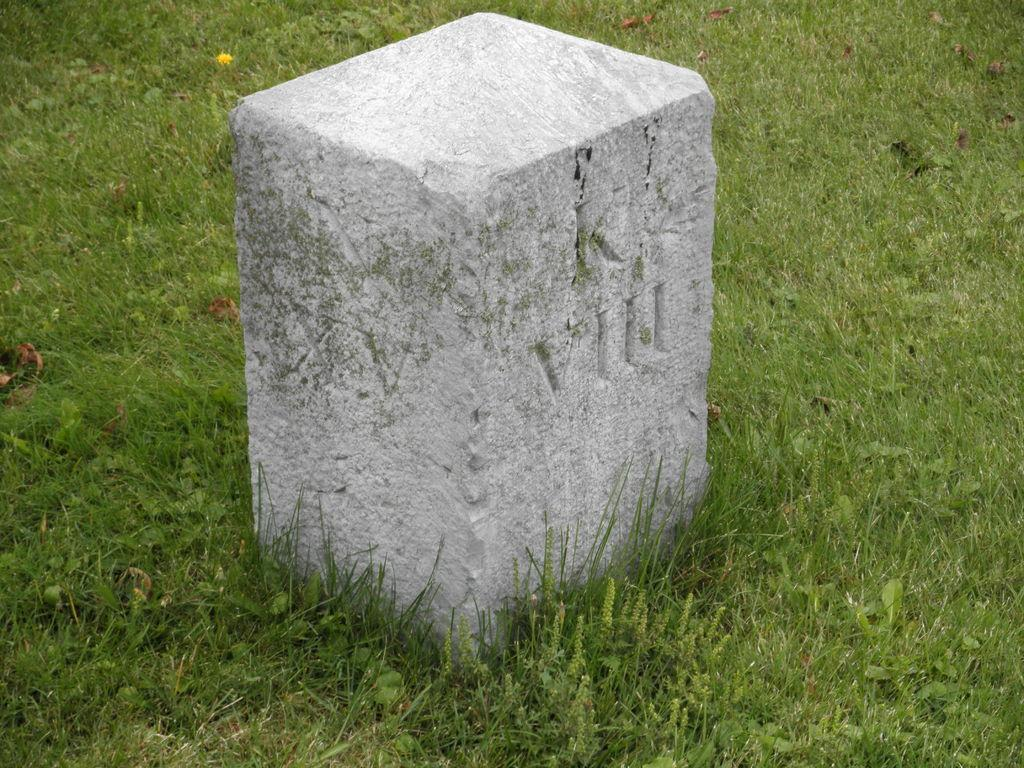What is the main subject in the middle of the image? There is a stone in the middle of the image. What type of vegetation is present at the bottom of the image? There is grass at the bottom of the image. Can you see a boat sailing through the grass in the image? No, there is no boat present in the image. The image features a stone and grass, with no indication of a boat or any water. 